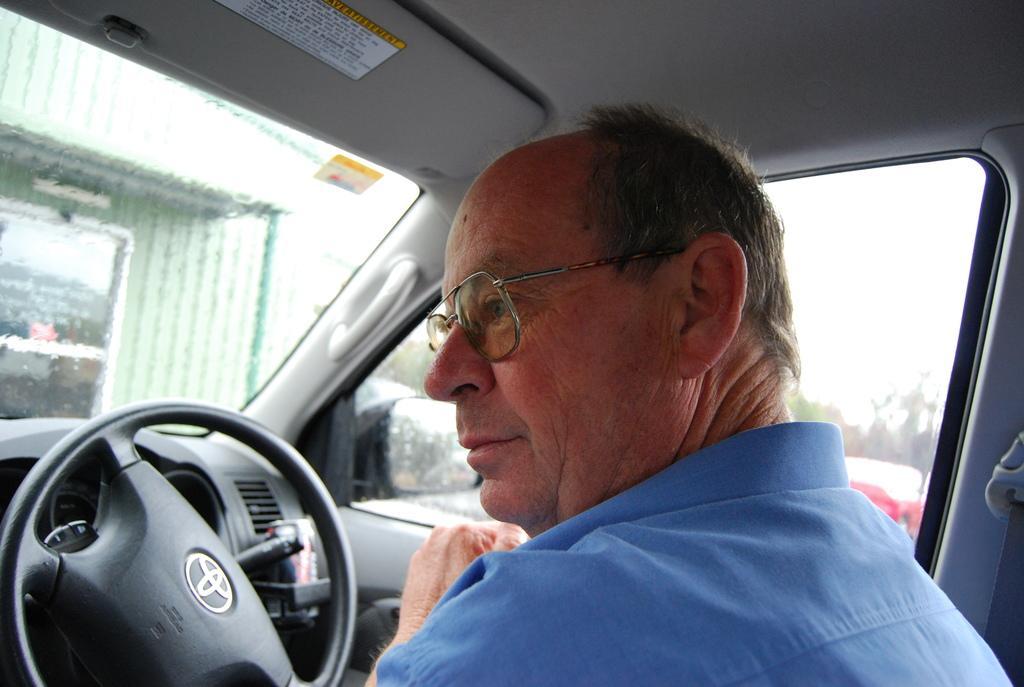Describe this image in one or two sentences. The image is inside the car. In the image there is a man who is sitting and he is also wearing his glasses in front of a steering. On right side of the man there is another car which is in red color. 